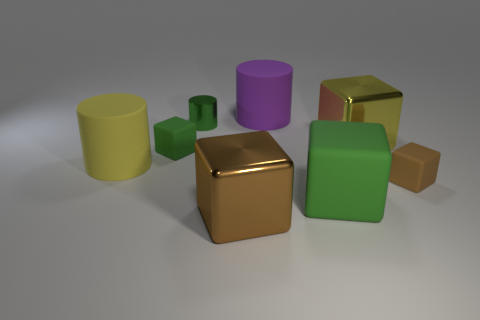Subtract all yellow blocks. How many blocks are left? 4 Add 1 big green matte objects. How many objects exist? 9 Subtract all cylinders. How many objects are left? 5 Add 7 shiny cylinders. How many shiny cylinders are left? 8 Add 2 small rubber blocks. How many small rubber blocks exist? 4 Subtract 0 red blocks. How many objects are left? 8 Subtract all small metal objects. Subtract all large yellow cylinders. How many objects are left? 6 